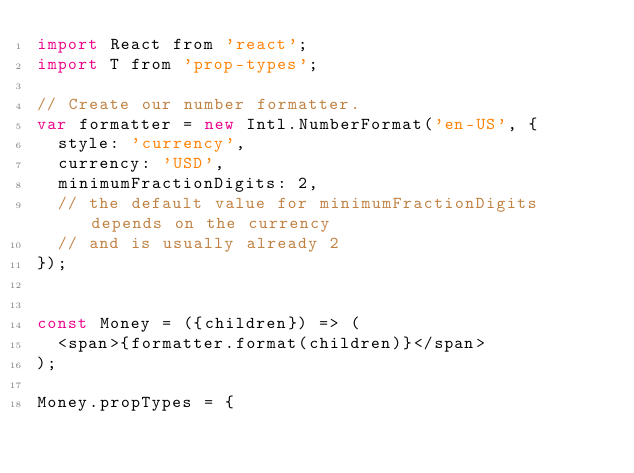<code> <loc_0><loc_0><loc_500><loc_500><_JavaScript_>import React from 'react';
import T from 'prop-types';

// Create our number formatter.
var formatter = new Intl.NumberFormat('en-US', {
  style: 'currency',
  currency: 'USD',
  minimumFractionDigits: 2,
  // the default value for minimumFractionDigits depends on the currency
  // and is usually already 2
});


const Money = ({children}) => (
  <span>{formatter.format(children)}</span>
);

Money.propTypes = {</code> 